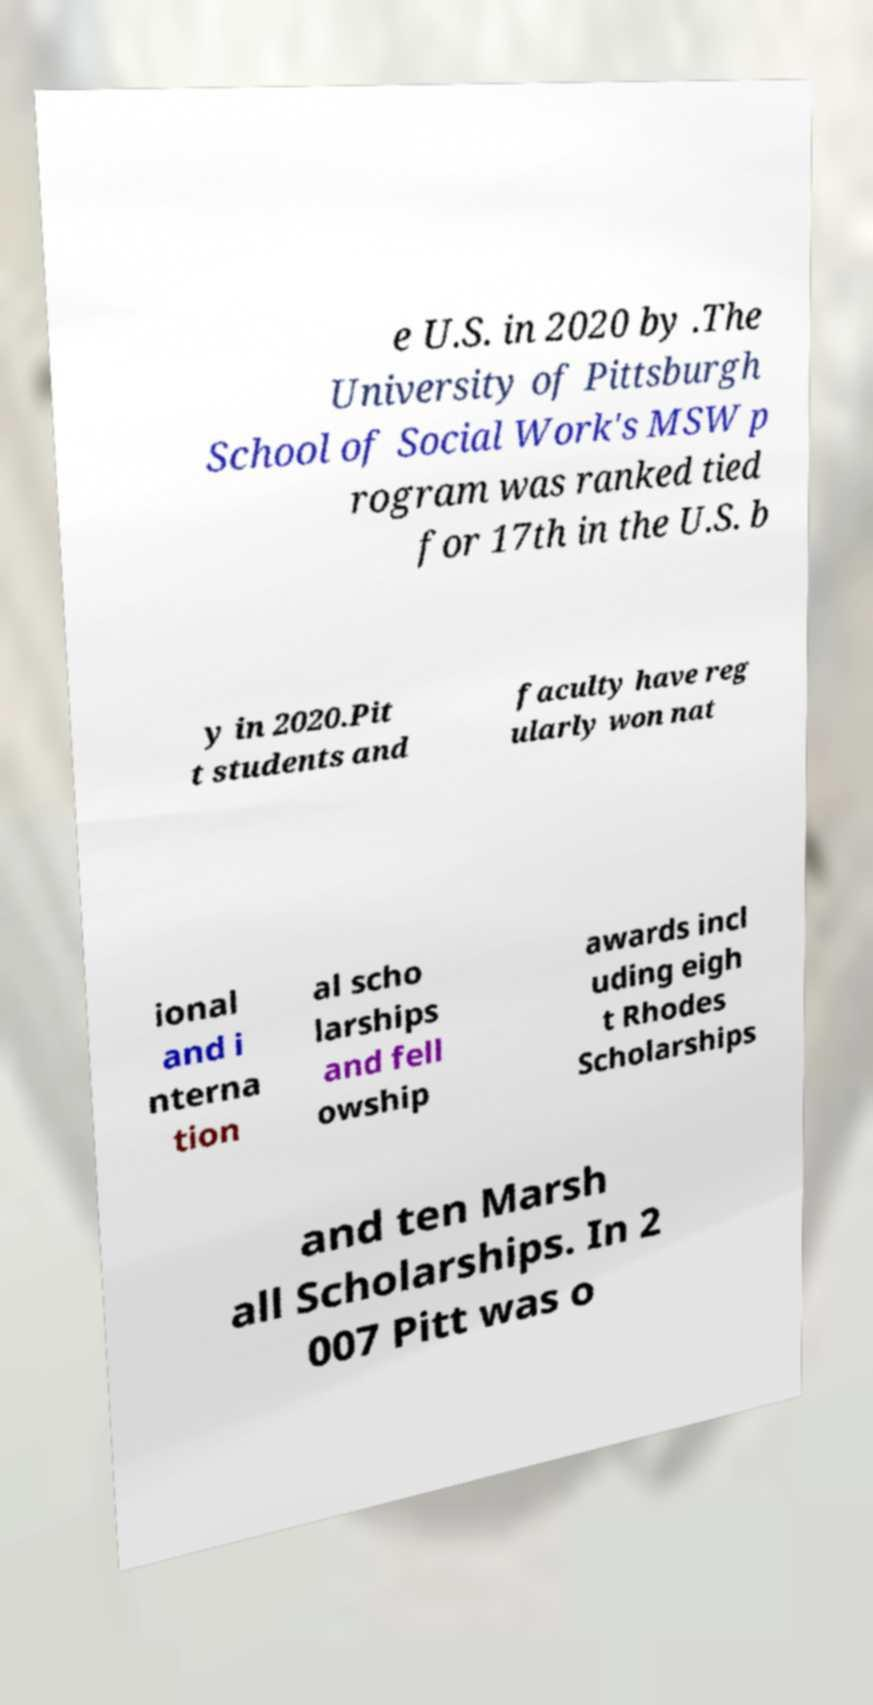Please read and relay the text visible in this image. What does it say? e U.S. in 2020 by .The University of Pittsburgh School of Social Work's MSW p rogram was ranked tied for 17th in the U.S. b y in 2020.Pit t students and faculty have reg ularly won nat ional and i nterna tion al scho larships and fell owship awards incl uding eigh t Rhodes Scholarships and ten Marsh all Scholarships. In 2 007 Pitt was o 